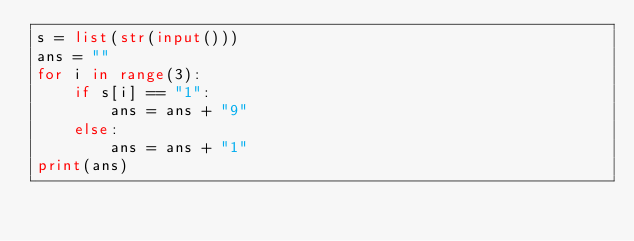Convert code to text. <code><loc_0><loc_0><loc_500><loc_500><_Python_>s = list(str(input()))
ans = ""
for i in range(3):
    if s[i] == "1":
        ans = ans + "9"
    else:
        ans = ans + "1"
print(ans)
</code> 